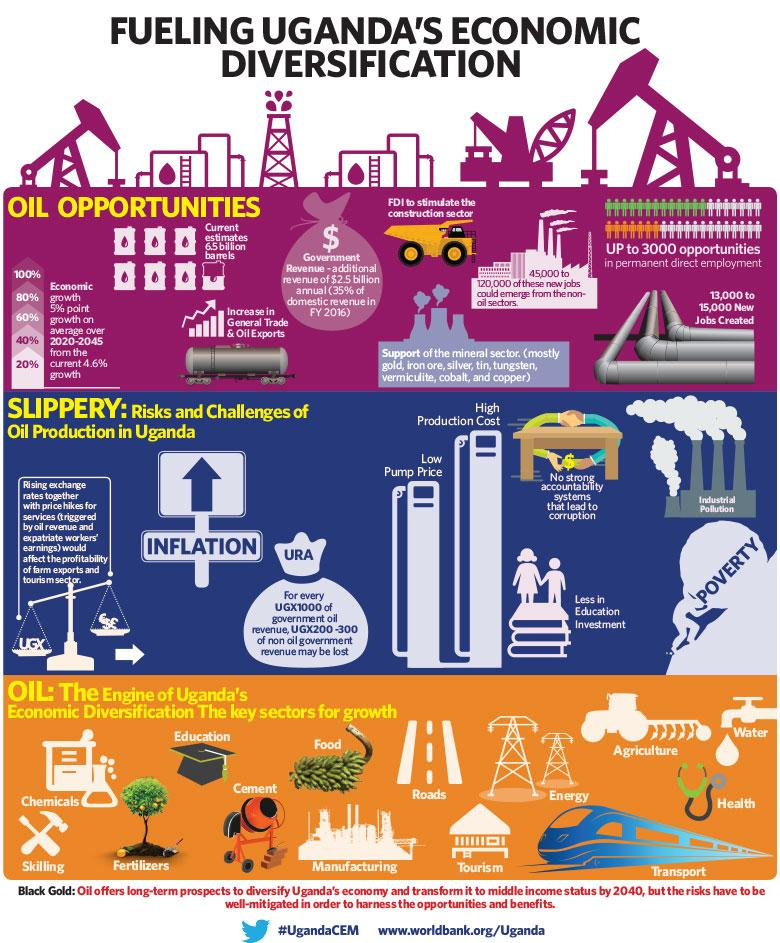Indicate a few pertinent items in this graphic. The second-to-last item listed among the risks and challenges of investing in education is a decrease in the value of the investment. Poverty is the risk and challenge that is listed last among the others. The lack of a strong accountability system can lead to corruption. It is expected that the growth will be 5% over the period of 2020-2045. The second risk shown in the image is inflation. 